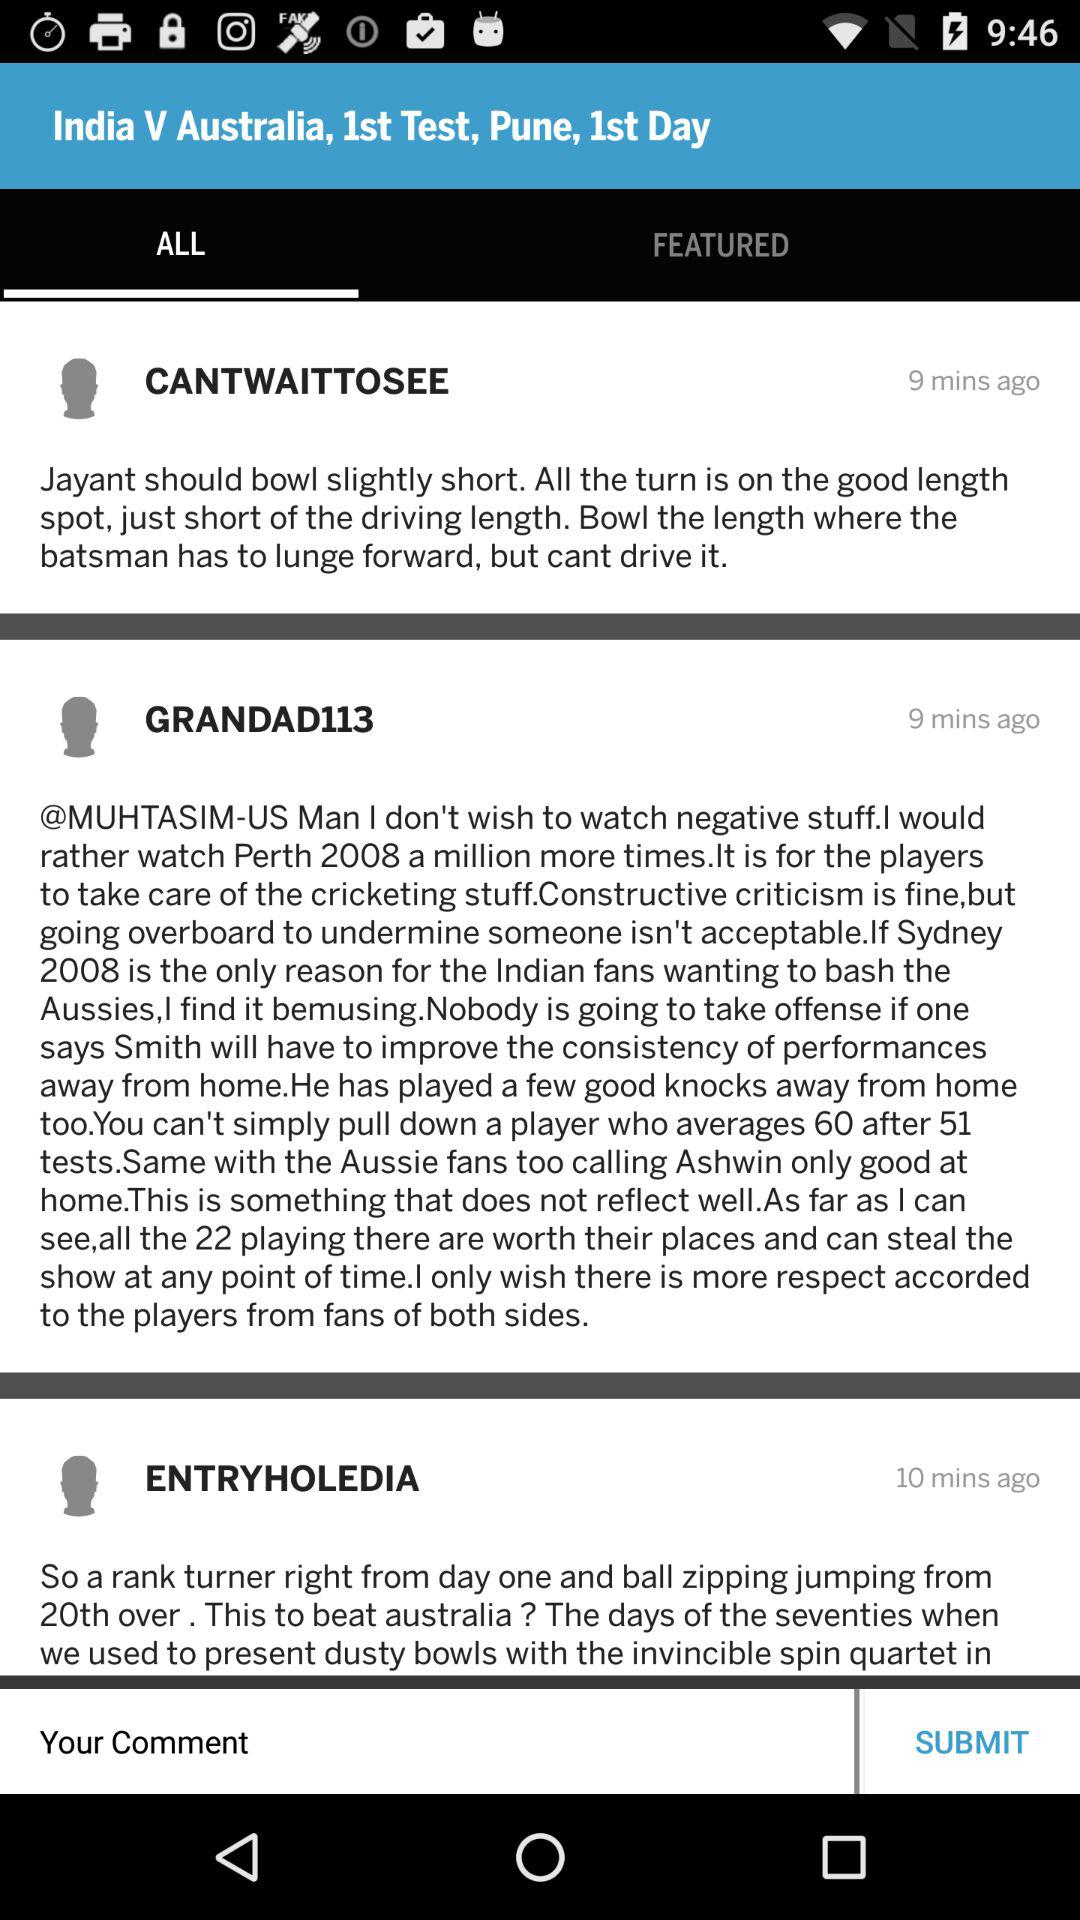How many comments are there on this page?
Answer the question using a single word or phrase. 3 